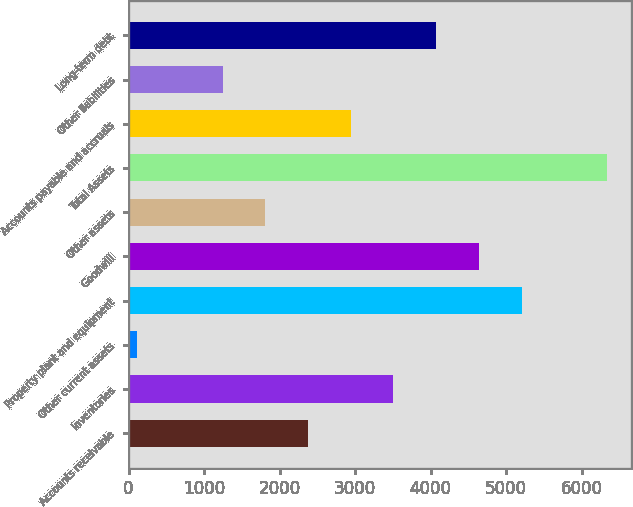Convert chart to OTSL. <chart><loc_0><loc_0><loc_500><loc_500><bar_chart><fcel>Accounts receivable<fcel>Inventories<fcel>Other current assets<fcel>Property plant and equipment<fcel>Goodwill<fcel>Other assets<fcel>Total Assets<fcel>Accounts payable and accruals<fcel>Other liabilities<fcel>Long-term debt<nl><fcel>2376<fcel>3508<fcel>112<fcel>5206<fcel>4640<fcel>1810<fcel>6338<fcel>2942<fcel>1244<fcel>4074<nl></chart> 